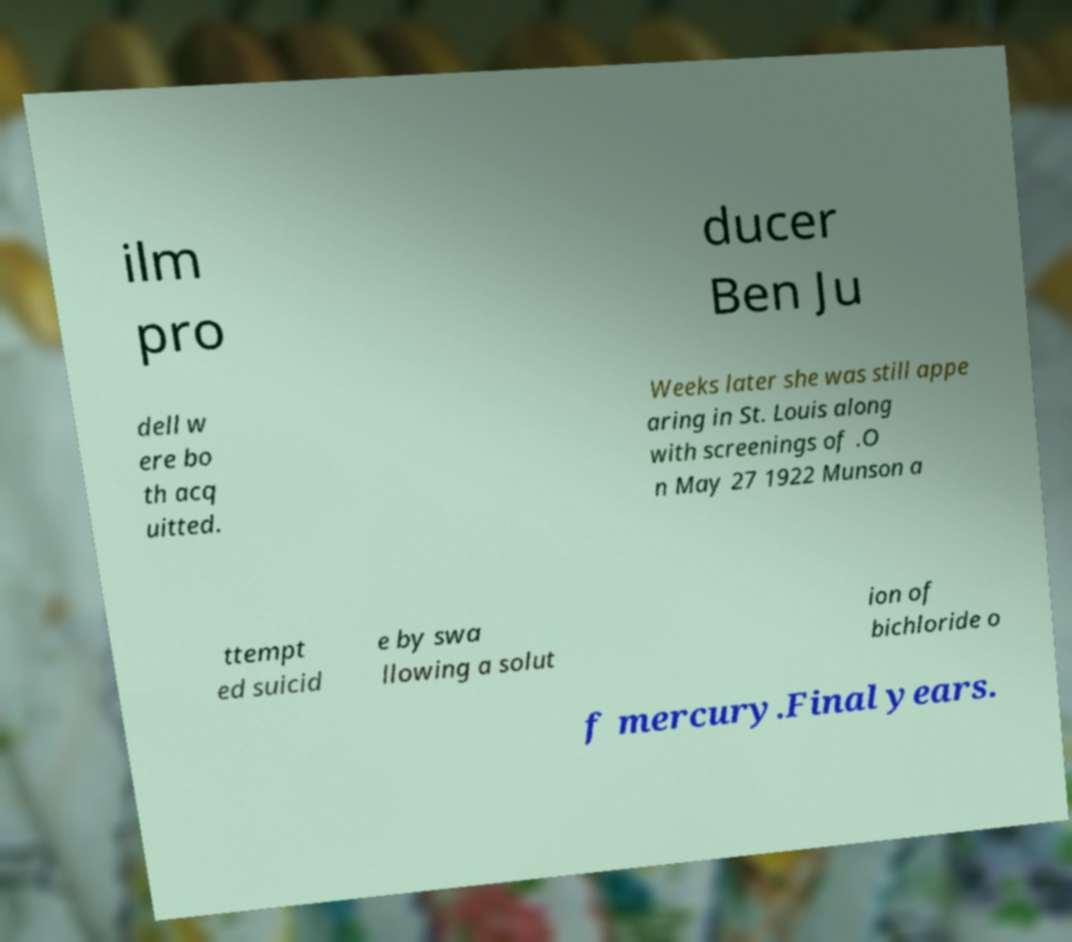Could you extract and type out the text from this image? ilm pro ducer Ben Ju dell w ere bo th acq uitted. Weeks later she was still appe aring in St. Louis along with screenings of .O n May 27 1922 Munson a ttempt ed suicid e by swa llowing a solut ion of bichloride o f mercury.Final years. 